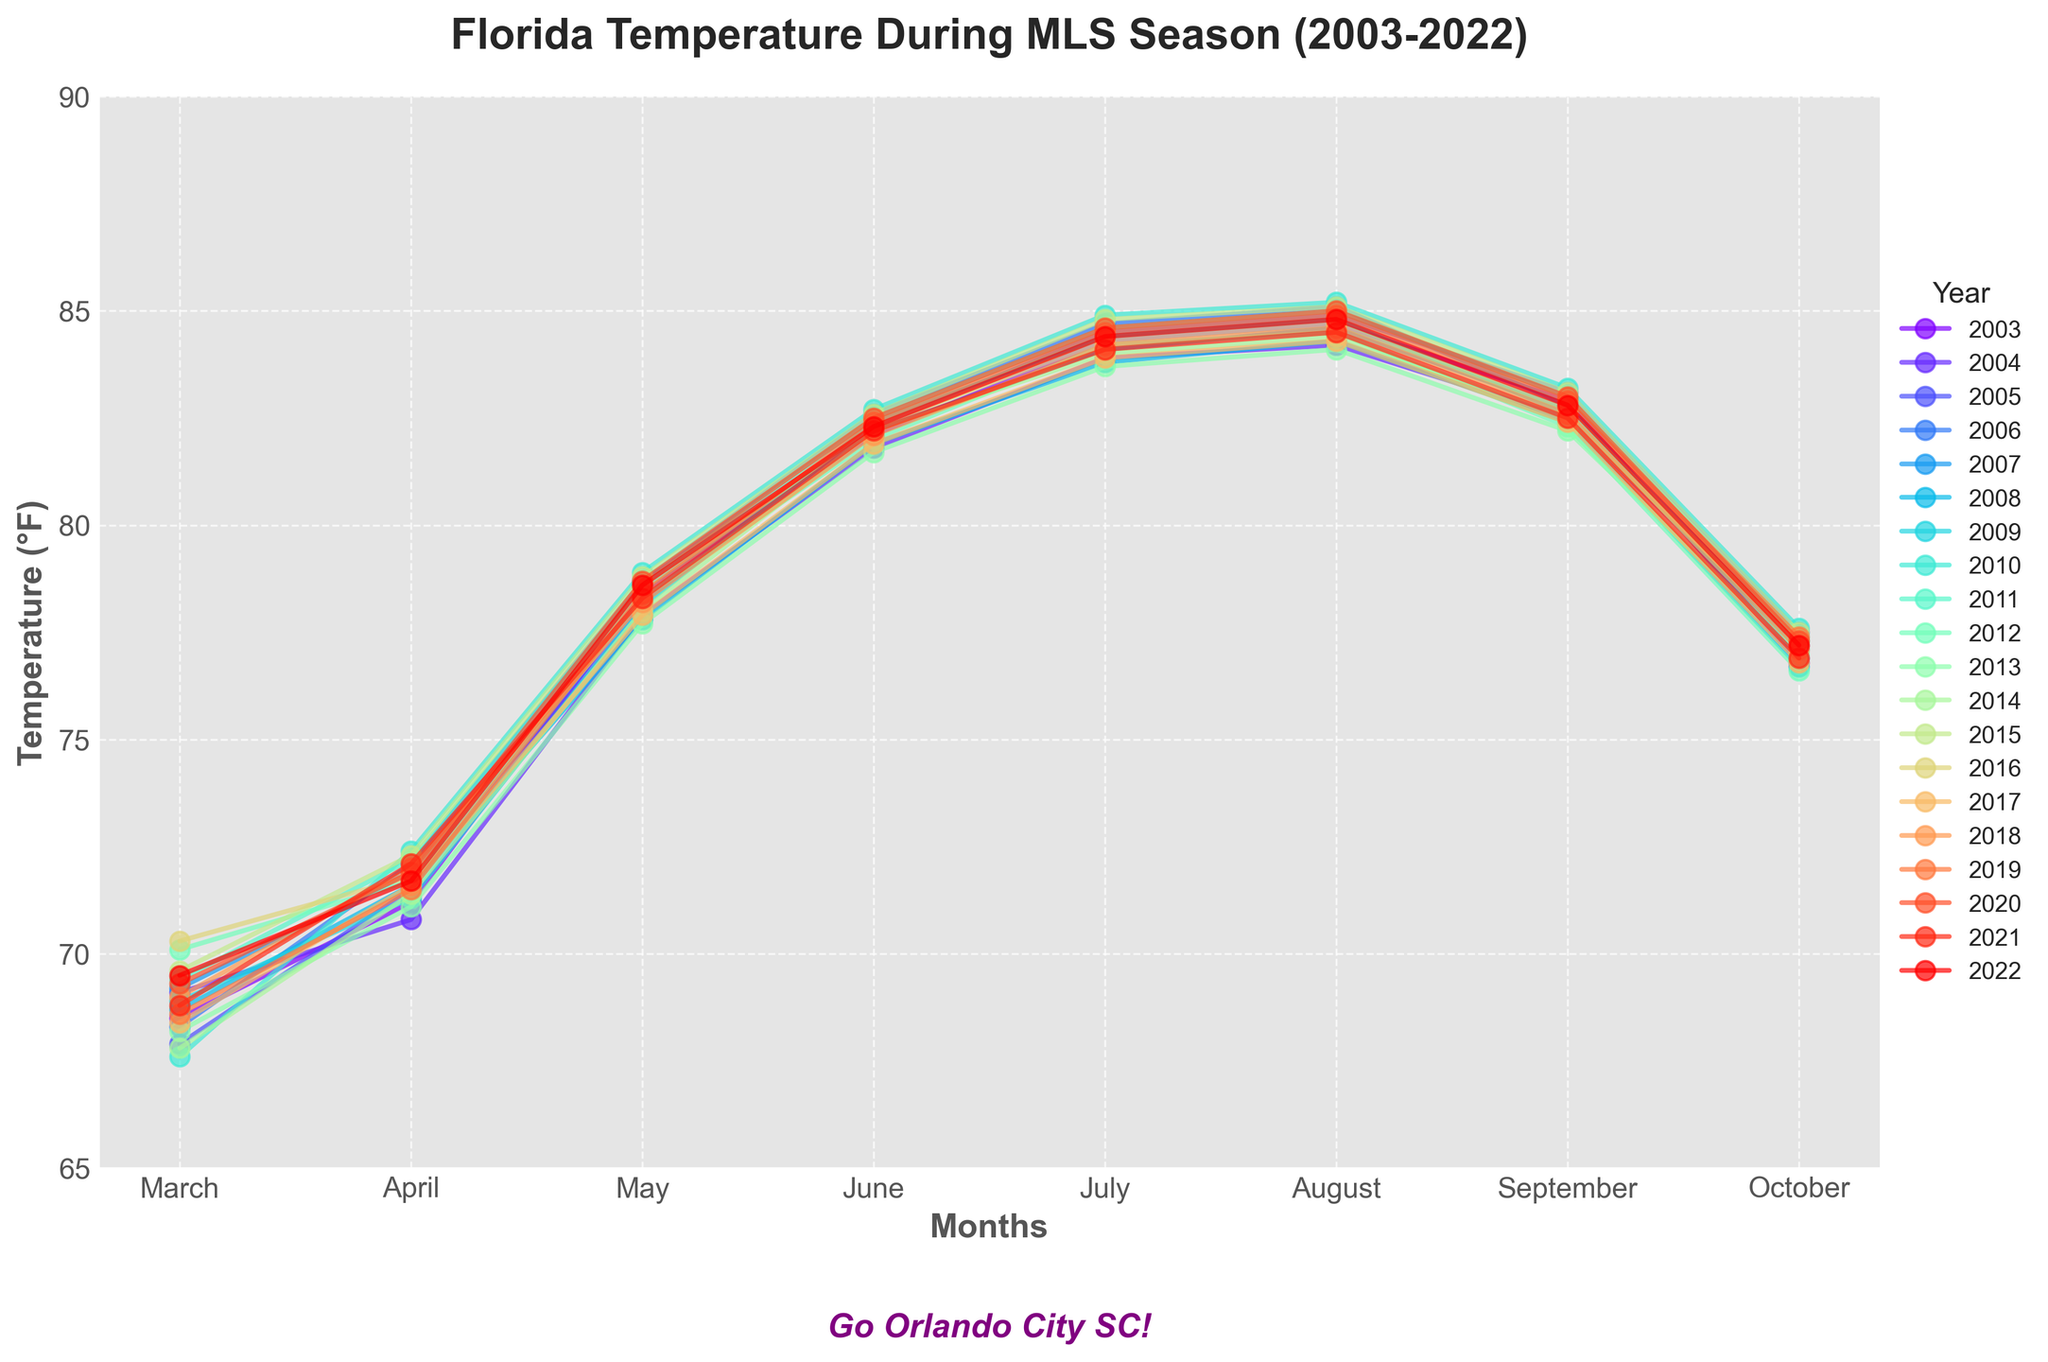what is the average temperature in August over the years? Sum of August values over the years is 84.7 + 84.2 + 84.9 + 85.1 + 84.6 + 84.3 + 84.8 + 85.2 + 85.0 + 84.5 + 84.1 + 84.4 + 85.1 + 84.7 + 84.3 + 84.6 + 84.9 + 85.0 + 84.5 + 84.8 = 1687.8. Average is 1687.8 / 20 = 84.39
Answer: 84.39 Which year had the highest temperature in June? Look for the highest point for the month June. The highest temperature in June was 82.7 in 2010.
Answer: 2010 Compare the temperatures in July and September for the year 2007. In 2007, July's temperature was 84.1 and September's temperature was 82.7. July was warmer than September in 2007.
Answer: July was warmer Which year had the lowest March temperature, and what was it? Track the lowest temperature point for March. The lowest March temperature was in 2010, at 67.6°F.
Answer: 2010, 67.6°F Is there any year where the temperature in October was higher than in September? Compare temperatures for September and October for each year. There is no year where the October temperature was higher than September.
Answer: No How many years had temperatures in July over 84°F? Count the years where July temperatures are greater than 84°F: 10 such years (2003, 2005, 2006, 2010, 2011, 2015, 2019, 2020, 2021, 2022).
Answer: 10 years What's the difference between August's highest and lowest temperature? Highest August temperature = 85.2 (2010), Lowest August temperature = 84.1 (2013). Difference = 85.2 - 84.1 = 1.1°F
Answer: 1.1°F Which year had the most stable temperature fluctuation (least variation) over the season? Calculate the range (max-min) for each year. 2017 with temperatures ranging 76.8 to 84.3 has the smallest fluctuation of 7.5°F.
Answer: 2017 What year had the coldest May, and what was the temperature? Look for the lowest May temperature point. The coldest May was in 2008, with 77.8°F.
Answer: 2008, 77.8°F What was the trend for July temperatures from 2003 to 2022? Observe the line plotting July temperatures. Generally, July temperatures remained fairly steady, slight peaks around 2010 and 2015.
Answer: Fairly steady 